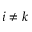<formula> <loc_0><loc_0><loc_500><loc_500>i \neq k</formula> 